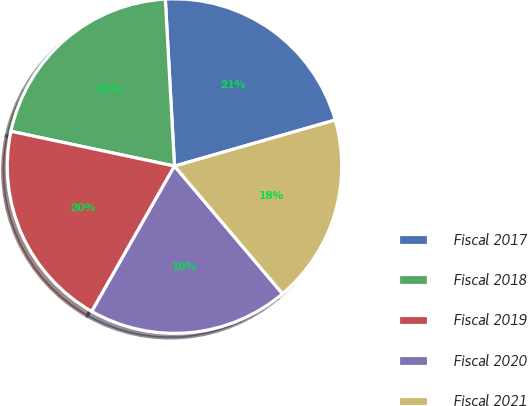Convert chart to OTSL. <chart><loc_0><loc_0><loc_500><loc_500><pie_chart><fcel>Fiscal 2017<fcel>Fiscal 2018<fcel>Fiscal 2019<fcel>Fiscal 2020<fcel>Fiscal 2021<nl><fcel>21.43%<fcel>20.79%<fcel>20.1%<fcel>19.41%<fcel>18.27%<nl></chart> 